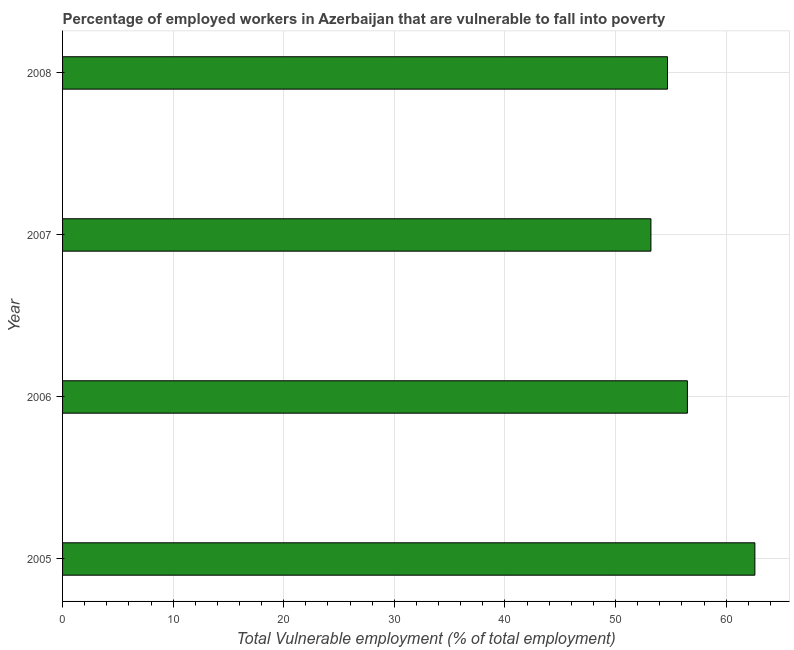Does the graph contain any zero values?
Offer a very short reply. No. Does the graph contain grids?
Offer a terse response. Yes. What is the title of the graph?
Your answer should be very brief. Percentage of employed workers in Azerbaijan that are vulnerable to fall into poverty. What is the label or title of the X-axis?
Offer a very short reply. Total Vulnerable employment (% of total employment). What is the label or title of the Y-axis?
Make the answer very short. Year. What is the total vulnerable employment in 2008?
Provide a short and direct response. 54.7. Across all years, what is the maximum total vulnerable employment?
Ensure brevity in your answer.  62.6. Across all years, what is the minimum total vulnerable employment?
Give a very brief answer. 53.2. In which year was the total vulnerable employment maximum?
Make the answer very short. 2005. In which year was the total vulnerable employment minimum?
Provide a short and direct response. 2007. What is the sum of the total vulnerable employment?
Provide a succinct answer. 227. What is the average total vulnerable employment per year?
Give a very brief answer. 56.75. What is the median total vulnerable employment?
Keep it short and to the point. 55.6. Do a majority of the years between 2008 and 2005 (inclusive) have total vulnerable employment greater than 62 %?
Give a very brief answer. Yes. Is the total vulnerable employment in 2007 less than that in 2008?
Provide a short and direct response. Yes. Is the difference between the total vulnerable employment in 2005 and 2006 greater than the difference between any two years?
Provide a short and direct response. No. Is the sum of the total vulnerable employment in 2005 and 2006 greater than the maximum total vulnerable employment across all years?
Give a very brief answer. Yes. What is the difference between the highest and the lowest total vulnerable employment?
Your answer should be very brief. 9.4. How many bars are there?
Keep it short and to the point. 4. Are all the bars in the graph horizontal?
Give a very brief answer. Yes. What is the difference between two consecutive major ticks on the X-axis?
Offer a terse response. 10. Are the values on the major ticks of X-axis written in scientific E-notation?
Your answer should be very brief. No. What is the Total Vulnerable employment (% of total employment) of 2005?
Provide a short and direct response. 62.6. What is the Total Vulnerable employment (% of total employment) in 2006?
Offer a very short reply. 56.5. What is the Total Vulnerable employment (% of total employment) in 2007?
Ensure brevity in your answer.  53.2. What is the Total Vulnerable employment (% of total employment) in 2008?
Give a very brief answer. 54.7. What is the difference between the Total Vulnerable employment (% of total employment) in 2005 and 2008?
Give a very brief answer. 7.9. What is the difference between the Total Vulnerable employment (% of total employment) in 2006 and 2008?
Make the answer very short. 1.8. What is the ratio of the Total Vulnerable employment (% of total employment) in 2005 to that in 2006?
Provide a succinct answer. 1.11. What is the ratio of the Total Vulnerable employment (% of total employment) in 2005 to that in 2007?
Ensure brevity in your answer.  1.18. What is the ratio of the Total Vulnerable employment (% of total employment) in 2005 to that in 2008?
Offer a very short reply. 1.14. What is the ratio of the Total Vulnerable employment (% of total employment) in 2006 to that in 2007?
Give a very brief answer. 1.06. What is the ratio of the Total Vulnerable employment (% of total employment) in 2006 to that in 2008?
Your answer should be very brief. 1.03. What is the ratio of the Total Vulnerable employment (% of total employment) in 2007 to that in 2008?
Provide a succinct answer. 0.97. 